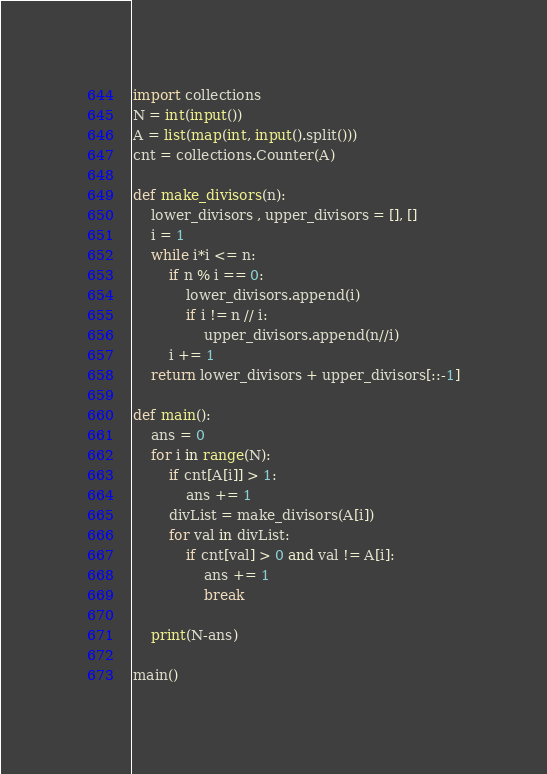<code> <loc_0><loc_0><loc_500><loc_500><_Python_>import collections
N = int(input())
A = list(map(int, input().split()))
cnt = collections.Counter(A)

def make_divisors(n):
    lower_divisors , upper_divisors = [], []
    i = 1
    while i*i <= n:
        if n % i == 0:
            lower_divisors.append(i)
            if i != n // i:
                upper_divisors.append(n//i)
        i += 1
    return lower_divisors + upper_divisors[::-1]

def main():
    ans = 0
    for i in range(N):
        if cnt[A[i]] > 1:
            ans += 1
        divList = make_divisors(A[i])
        for val in divList:
            if cnt[val] > 0 and val != A[i]:
                ans += 1
                break

    print(N-ans)

main()</code> 